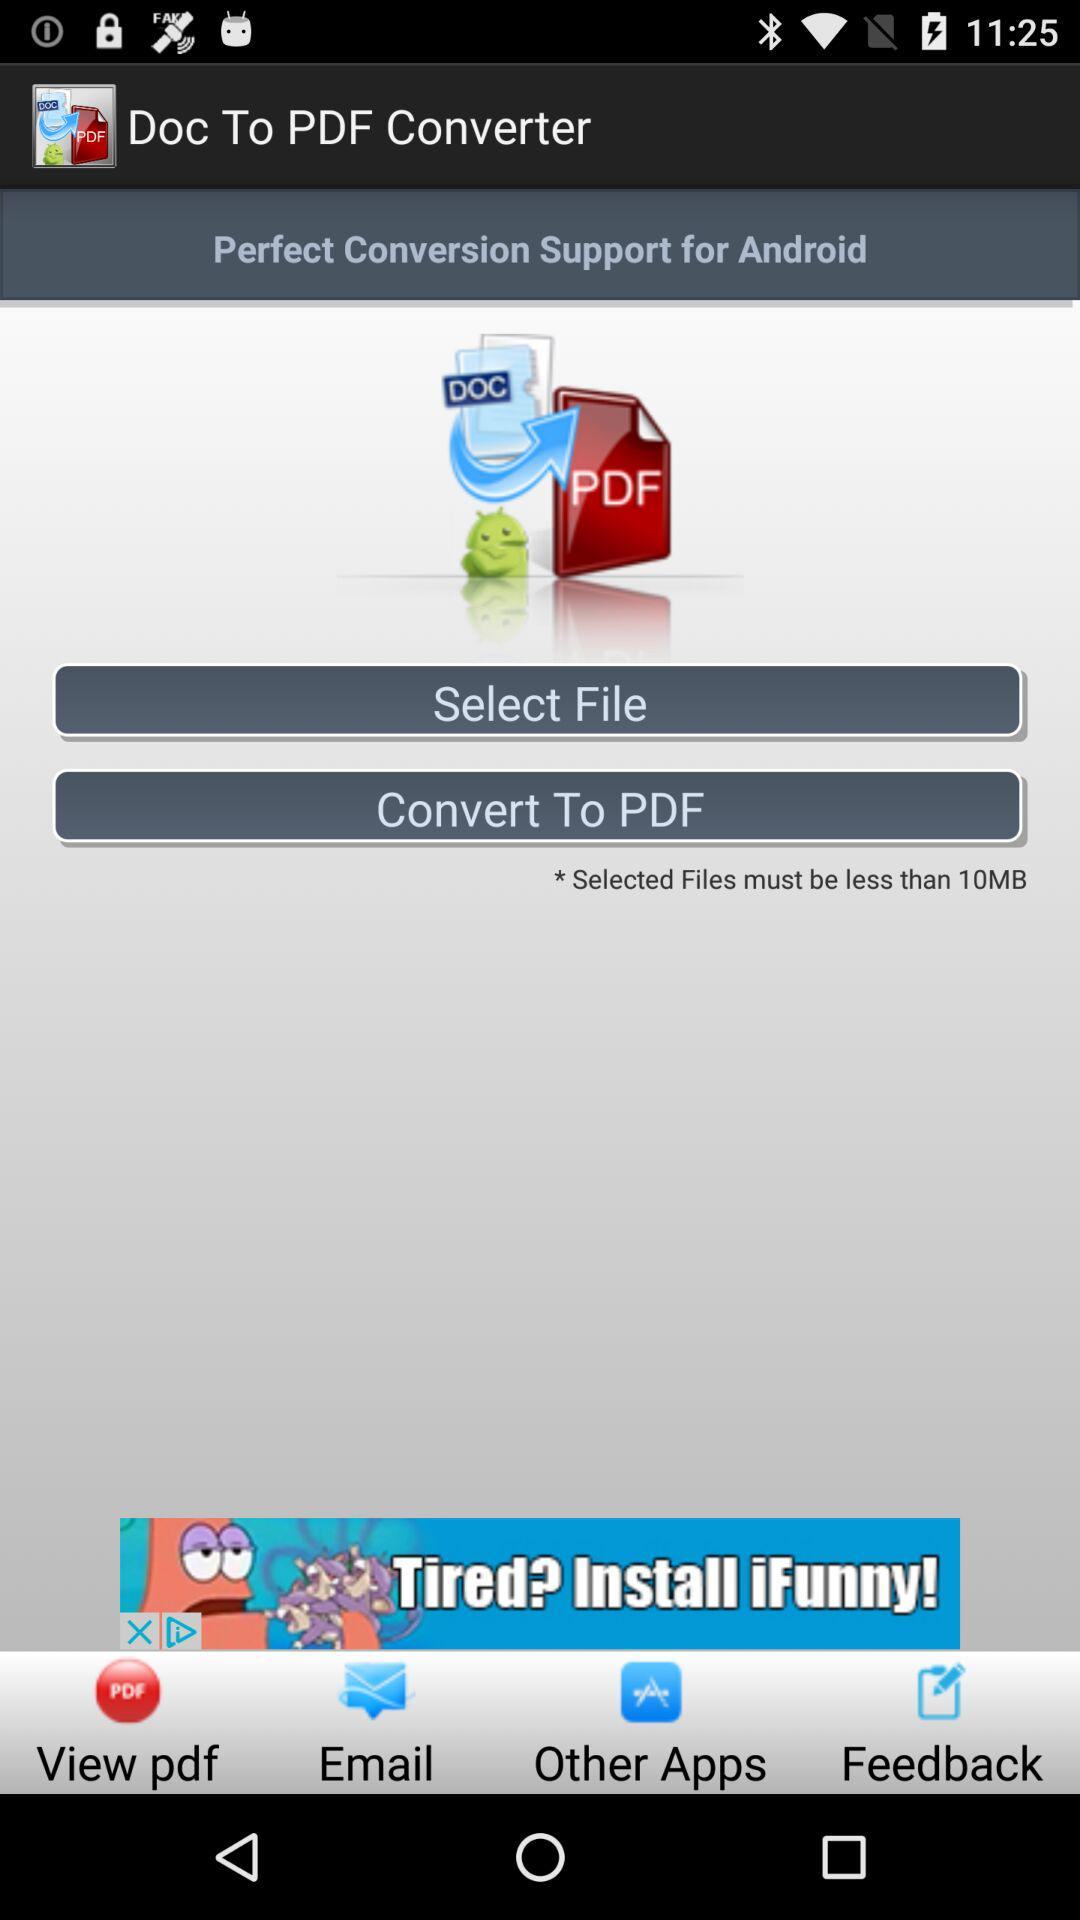What is the name of the application? The application name is Doc To PDF Converter. 